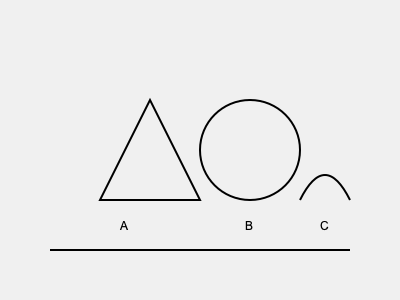Analyze the petroglyphs depicted in the image above, commonly found in northern Chilean archaeological sites. Which symbol is most likely associated with fertility and abundance in pre-Columbian Andean cultures, and why? To answer this question, we need to consider the symbolic meanings of geometric shapes in pre-Columbian Andean cultures:

1. Triangle (Symbol A):
   - Represents mountains or pyramids
   - Often associated with male energy or deities
   - Not typically linked to fertility or abundance

2. Circle (Symbol B):
   - Symbolizes completeness, cycles, and unity
   - In many cultures, represents the sun or moon
   - Often associated with fertility and abundance due to its round shape resembling a pregnant belly or full moon

3. Curved line (Symbol C):
   - May represent water, rivers, or snakes
   - While important, not as strongly linked to fertility as the circle

Considering these interpretations:

- The circle (Symbol B) is most likely associated with fertility and abundance in pre-Columbian Andean cultures.
- Its shape resembles a full moon or pregnant belly, both symbols of fertility.
- Circles often represent cyclical nature, which is closely tied to agricultural cycles and abundance.
- In many Andean cultures, circular shapes were used to depict celestial bodies like the sun or moon, which were crucial for agricultural planning and thus linked to abundance.

Therefore, among the given symbols, the circle (Symbol B) is the most probable representation of fertility and abundance in this context.
Answer: Symbol B (circle) 